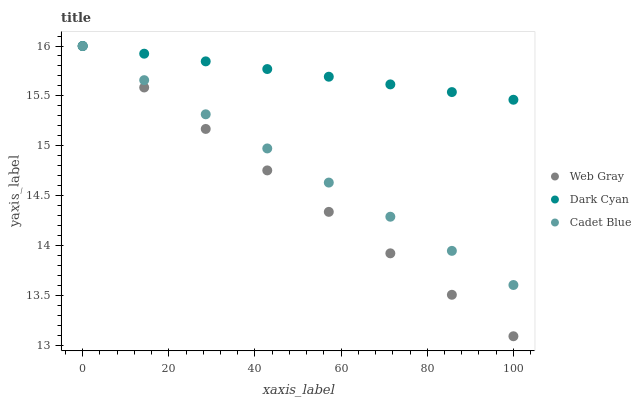Does Web Gray have the minimum area under the curve?
Answer yes or no. Yes. Does Dark Cyan have the maximum area under the curve?
Answer yes or no. Yes. Does Cadet Blue have the minimum area under the curve?
Answer yes or no. No. Does Cadet Blue have the maximum area under the curve?
Answer yes or no. No. Is Dark Cyan the smoothest?
Answer yes or no. Yes. Is Web Gray the roughest?
Answer yes or no. Yes. Is Cadet Blue the smoothest?
Answer yes or no. No. Is Cadet Blue the roughest?
Answer yes or no. No. Does Web Gray have the lowest value?
Answer yes or no. Yes. Does Cadet Blue have the lowest value?
Answer yes or no. No. Does Cadet Blue have the highest value?
Answer yes or no. Yes. Does Web Gray intersect Cadet Blue?
Answer yes or no. Yes. Is Web Gray less than Cadet Blue?
Answer yes or no. No. Is Web Gray greater than Cadet Blue?
Answer yes or no. No. 